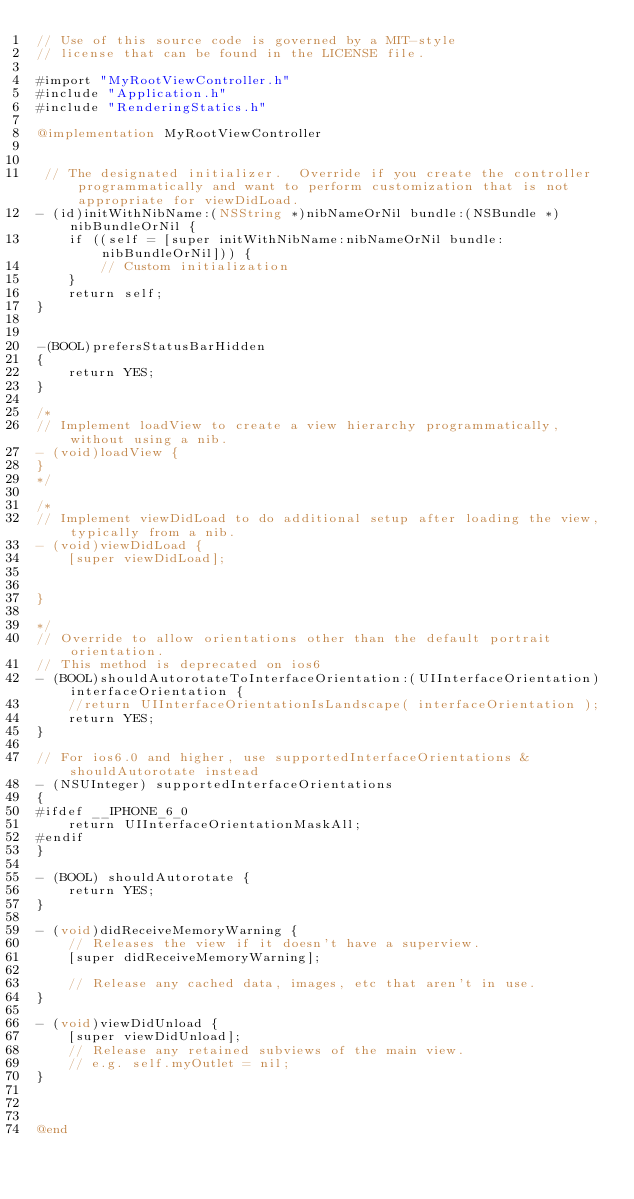<code> <loc_0><loc_0><loc_500><loc_500><_ObjectiveC_>// Use of this source code is governed by a MIT-style
// license that can be found in the LICENSE file.

#import "MyRootViewController.h"
#include "Application.h"
#include "RenderingStatics.h"

@implementation MyRootViewController


 // The designated initializer.  Override if you create the controller programmatically and want to perform customization that is not appropriate for viewDidLoad.
- (id)initWithNibName:(NSString *)nibNameOrNil bundle:(NSBundle *)nibBundleOrNil {
    if ((self = [super initWithNibName:nibNameOrNil bundle:nibBundleOrNil])) {
        // Custom initialization
    }
    return self;
}


-(BOOL)prefersStatusBarHidden
{
    return YES;
}

/*
// Implement loadView to create a view hierarchy programmatically, without using a nib.
- (void)loadView {
}
*/

/*
// Implement viewDidLoad to do additional setup after loading the view, typically from a nib.
- (void)viewDidLoad {
    [super viewDidLoad];

	
}
 
*/
// Override to allow orientations other than the default portrait orientation.
// This method is deprecated on ios6
- (BOOL)shouldAutorotateToInterfaceOrientation:(UIInterfaceOrientation)interfaceOrientation {
    //return UIInterfaceOrientationIsLandscape( interfaceOrientation );
    return YES;
}

// For ios6.0 and higher, use supportedInterfaceOrientations & shouldAutorotate instead
- (NSUInteger) supportedInterfaceOrientations
{
#ifdef __IPHONE_6_0
    return UIInterfaceOrientationMaskAll;
#endif
}

- (BOOL) shouldAutorotate {
    return YES;
}

- (void)didReceiveMemoryWarning {
    // Releases the view if it doesn't have a superview.
    [super didReceiveMemoryWarning];
    
    // Release any cached data, images, etc that aren't in use.
}

- (void)viewDidUnload {
    [super viewDidUnload];
    // Release any retained subviews of the main view.
    // e.g. self.myOutlet = nil;
}



@end
</code> 